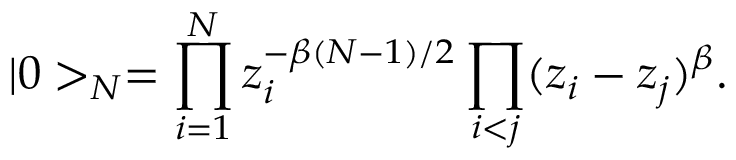<formula> <loc_0><loc_0><loc_500><loc_500>| 0 > _ { N } = \prod _ { i = 1 } ^ { N } z _ { i } ^ { - \beta ( N - 1 ) / 2 } \prod _ { i < j } ( z _ { i } - z _ { j } ) ^ { \beta } .</formula> 